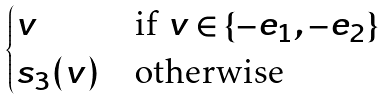<formula> <loc_0><loc_0><loc_500><loc_500>\begin{cases} v & \text {if $v \in \{-e_{1}, -e_{2}\}$} \\ s _ { 3 } ( v ) & \text {otherwise} \end{cases}</formula> 